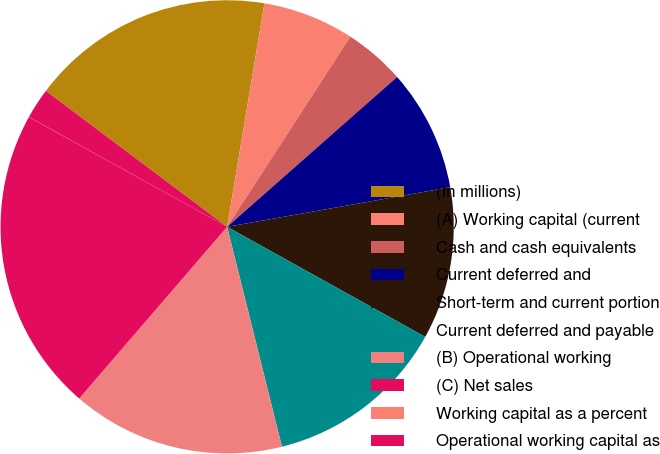<chart> <loc_0><loc_0><loc_500><loc_500><pie_chart><fcel>(In millions)<fcel>(A) Working capital (current<fcel>Cash and cash equivalents<fcel>Current deferred and<fcel>Short-term and current portion<fcel>Current deferred and payable<fcel>(B) Operational working<fcel>(C) Net sales<fcel>Working capital as a percent<fcel>Operational working capital as<nl><fcel>17.39%<fcel>6.52%<fcel>4.35%<fcel>8.7%<fcel>10.87%<fcel>13.04%<fcel>15.21%<fcel>21.73%<fcel>0.01%<fcel>2.18%<nl></chart> 